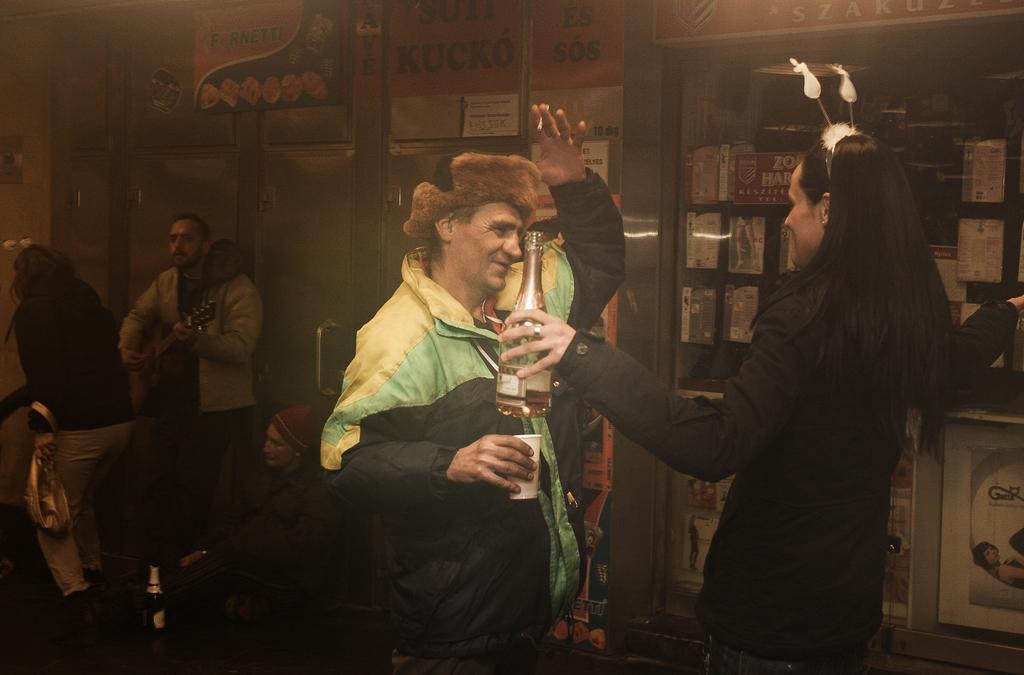How would you summarize this image in a sentence or two? In this picture we can see a person holding a bottle in hand. There is a man holding a cup. There is another person playing guitar. We can see a bottle on the path. Few people are visible at the back. There are some boxes on the right side. 